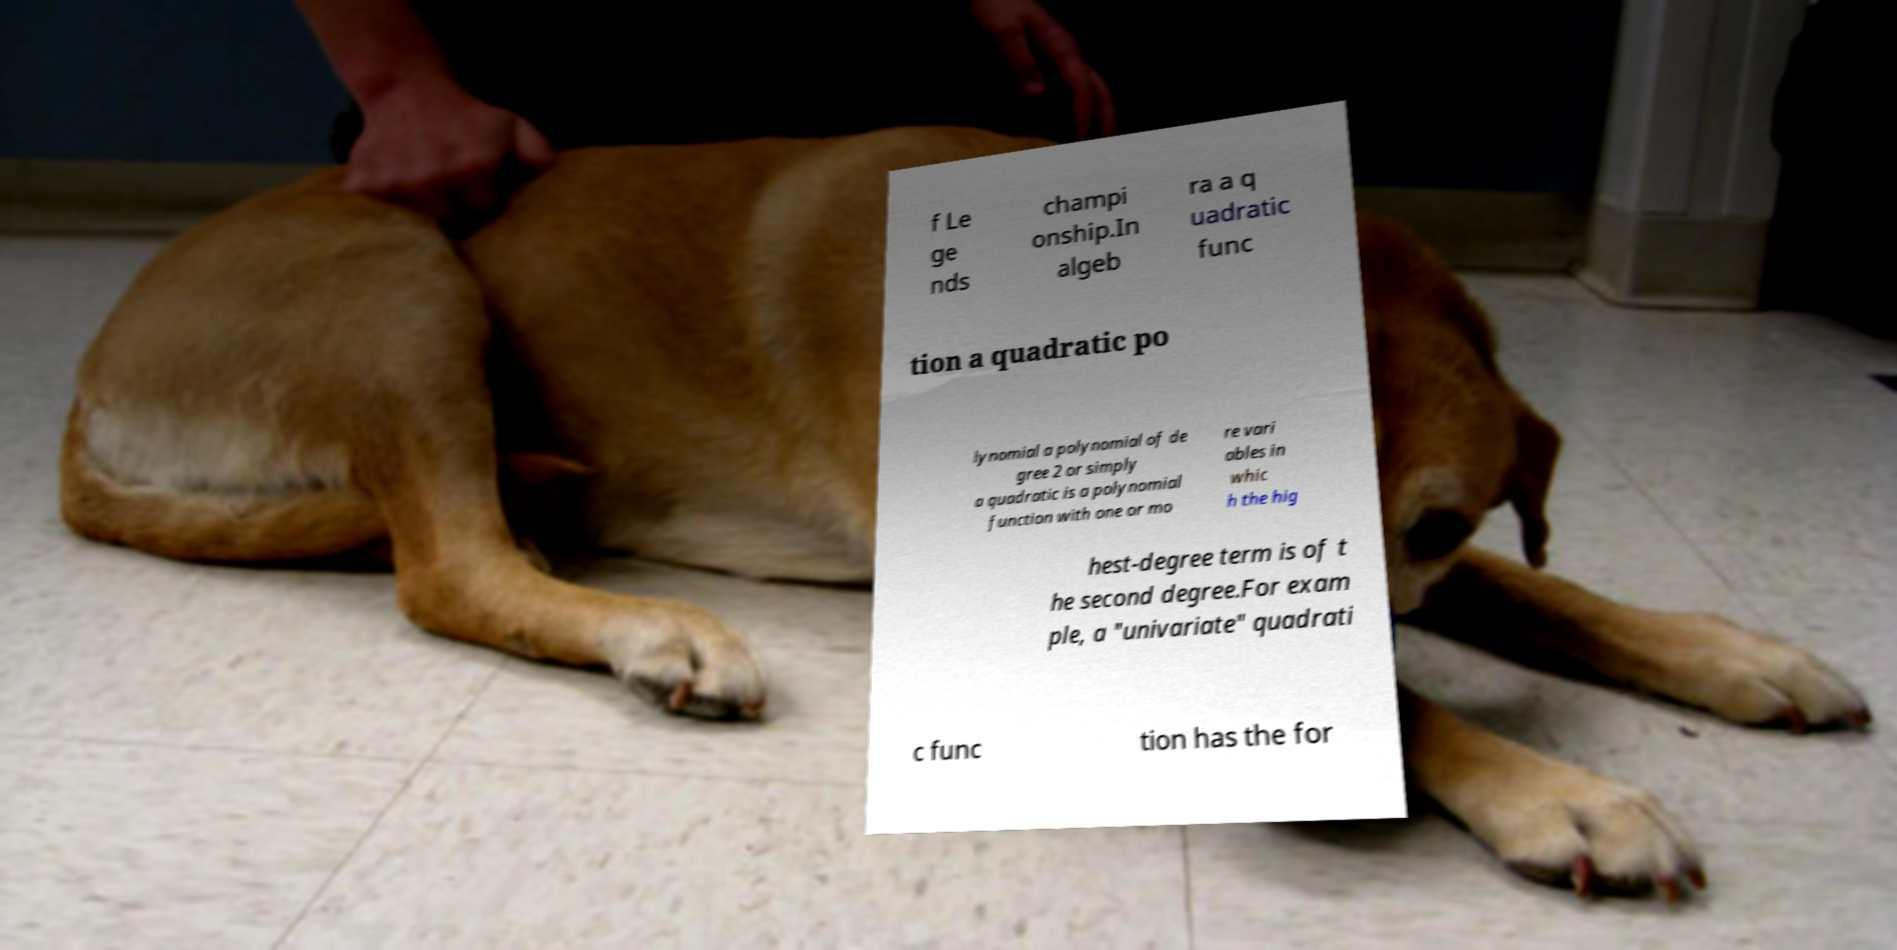For documentation purposes, I need the text within this image transcribed. Could you provide that? f Le ge nds champi onship.In algeb ra a q uadratic func tion a quadratic po lynomial a polynomial of de gree 2 or simply a quadratic is a polynomial function with one or mo re vari ables in whic h the hig hest-degree term is of t he second degree.For exam ple, a "univariate" quadrati c func tion has the for 